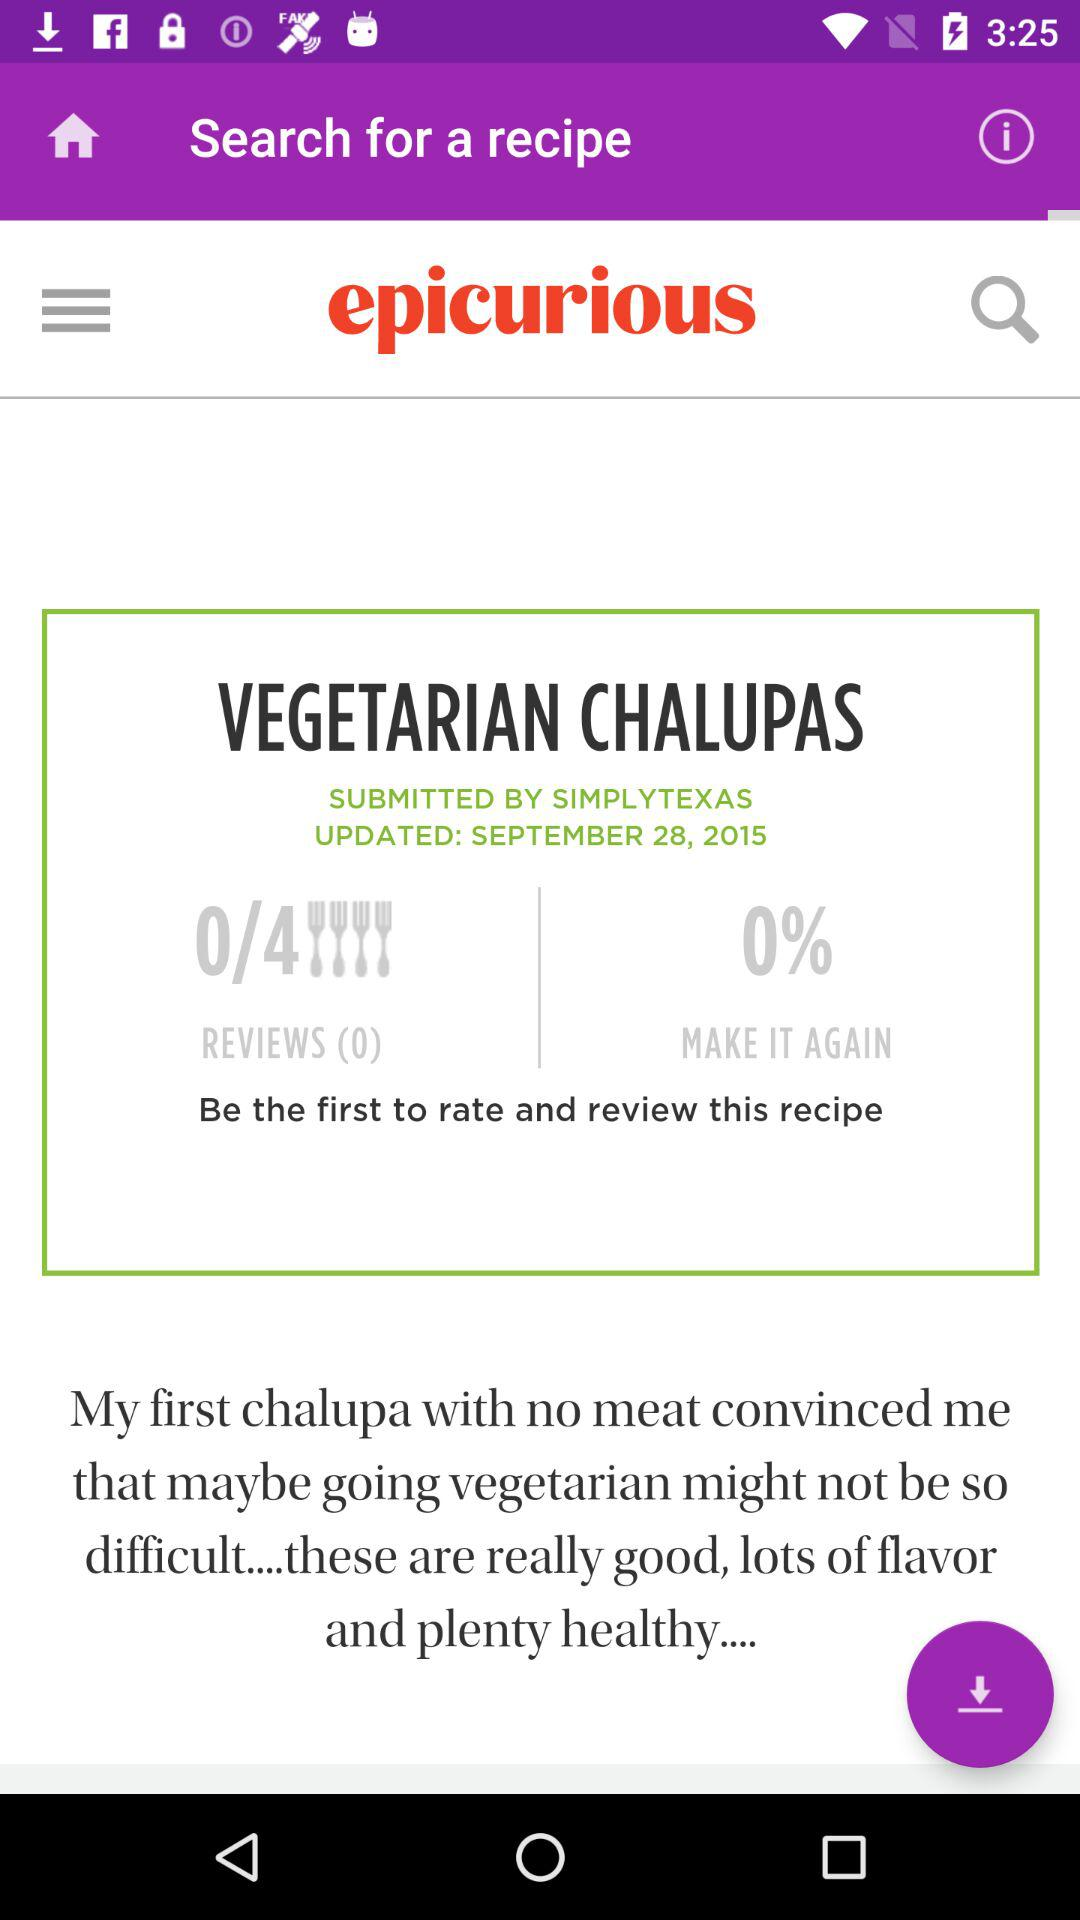How many reviews are there for this recipe?
Answer the question using a single word or phrase. 0 